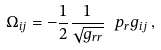<formula> <loc_0><loc_0><loc_500><loc_500>\Omega _ { i j } = - \frac { 1 } { 2 } \frac { 1 } { \sqrt { g _ { r r } } } \ p _ { r } g _ { i j } \, ,</formula> 